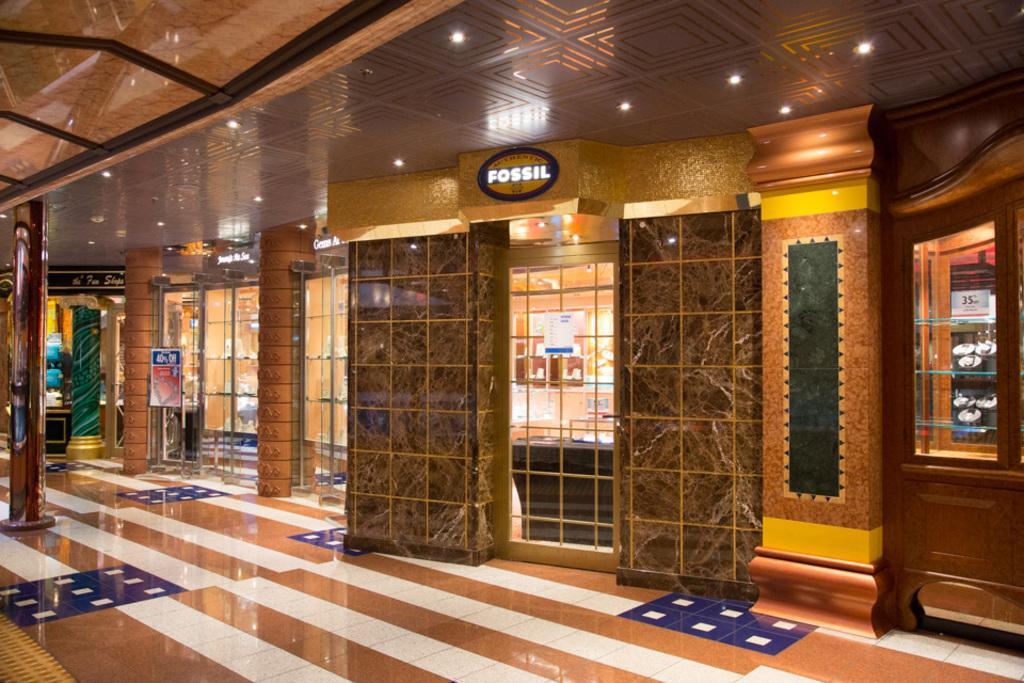In one or two sentences, can you explain what this image depicts? This image is clicked inside a building. In the middle there are pillars, posters, doors, grills, text, lighting's, shelves and floor. 